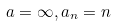Convert formula to latex. <formula><loc_0><loc_0><loc_500><loc_500>a = \infty , a _ { n } = n</formula> 